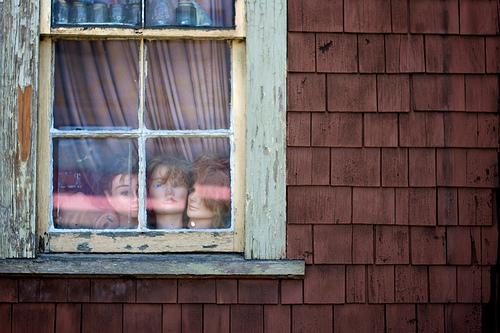<image>
Can you confirm if the person is under the window? No. The person is not positioned under the window. The vertical relationship between these objects is different. Is the mannequin behind the window? Yes. From this viewpoint, the mannequin is positioned behind the window, with the window partially or fully occluding the mannequin. 